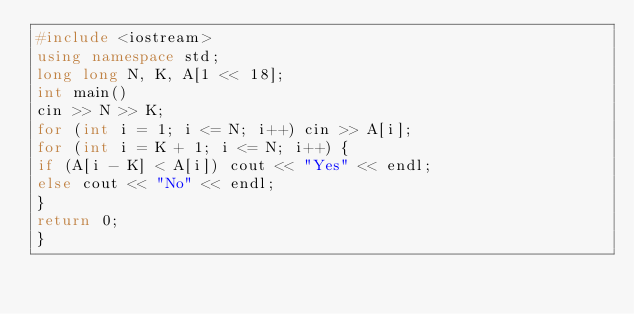Convert code to text. <code><loc_0><loc_0><loc_500><loc_500><_C++_>#include <iostream>
using namespace std;
long long N, K, A[1 << 18];
int main() 
cin >> N >> K;
for (int i = 1; i <= N; i++) cin >> A[i];
for (int i = K + 1; i <= N; i++) {
if (A[i - K] < A[i]) cout << "Yes" << endl;
else cout << "No" << endl;
}
return 0;
}</code> 